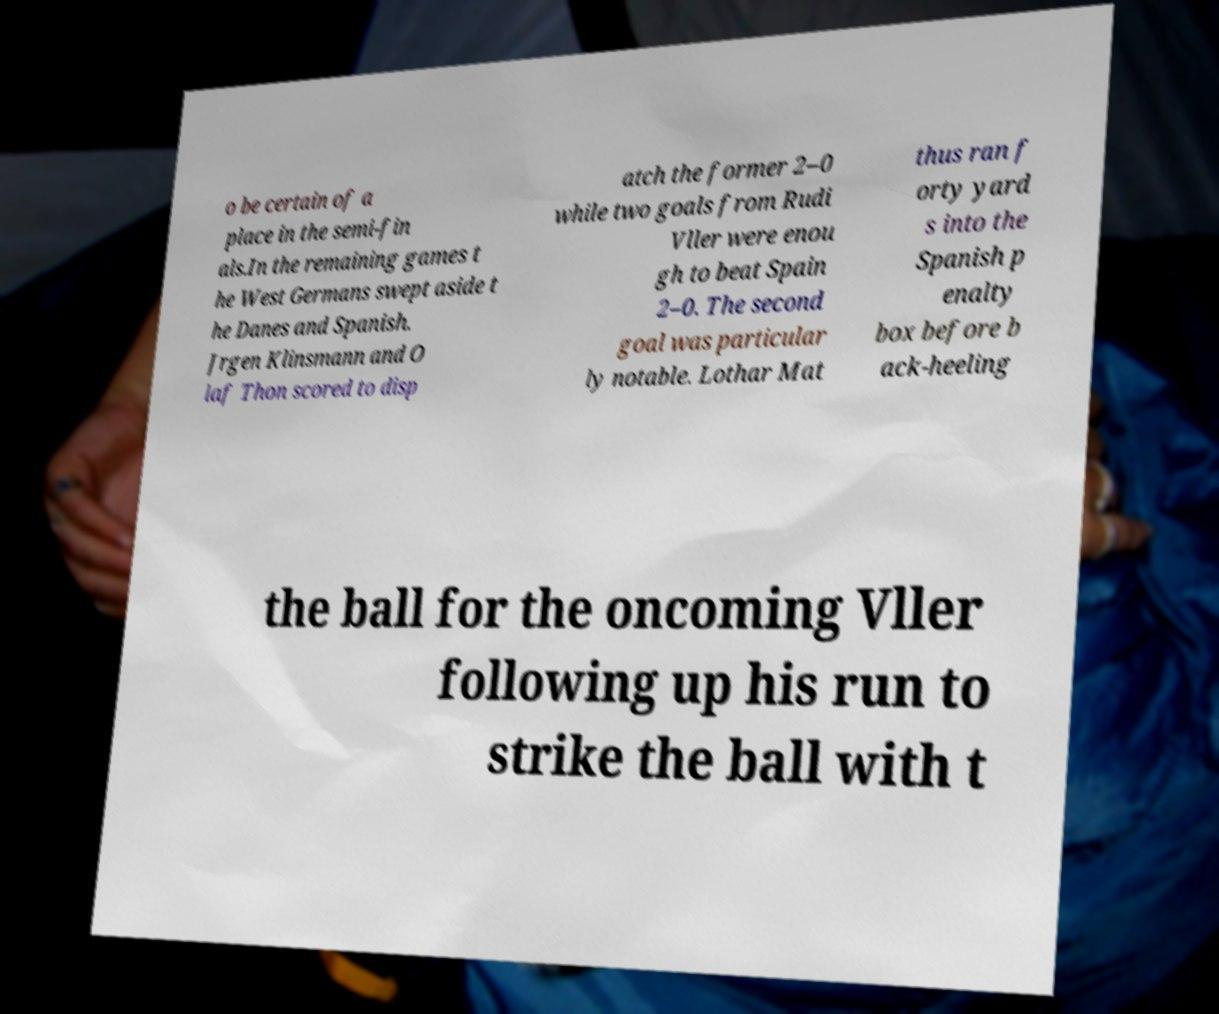I need the written content from this picture converted into text. Can you do that? o be certain of a place in the semi-fin als.In the remaining games t he West Germans swept aside t he Danes and Spanish. Jrgen Klinsmann and O laf Thon scored to disp atch the former 2–0 while two goals from Rudi Vller were enou gh to beat Spain 2–0. The second goal was particular ly notable. Lothar Mat thus ran f orty yard s into the Spanish p enalty box before b ack-heeling the ball for the oncoming Vller following up his run to strike the ball with t 